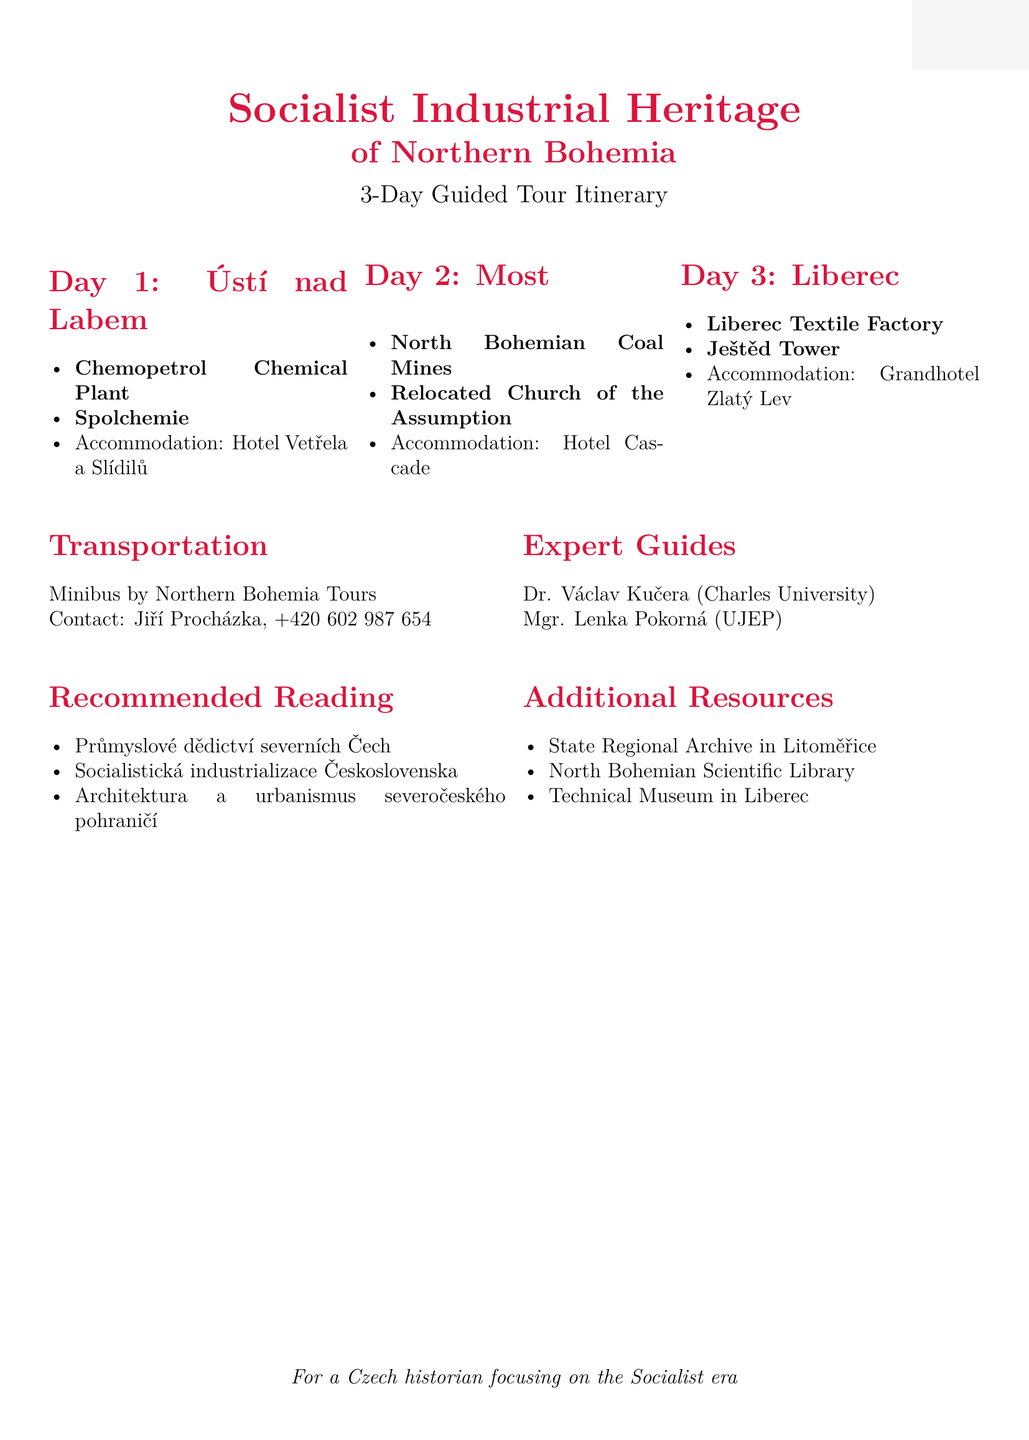What is the tour name? The tour name is stated at the beginning of the document.
Answer: Socialist Industrial Heritage of Northern Bohemia How many days does the tour last? The duration of the tour is mentioned clearly in the document.
Answer: 3 days Who is the contact person for Chemopetrol Chemical Plant? The document provides specific contacts for each site visited during the tour.
Answer: Miroslav Novák, Industrial Heritage Guide, +420 605 123 456 What type of transportation is provided? The document specifies the type of transport arranged for the tour.
Answer: Minibus What is the accommodation in Most? Each location in the tour lists its corresponding accommodation.
Answer: Hotel Cascade, Radniční 3, 434 01 Most Which expert guide specializes in economic history? The document lists expert guides along with their specializations.
Answer: Mgr. Lenka Pokorná When was the Ještěd Tower built? The document provides the construction period of the Ještěd Tower.
Answer: 1966-1973 What is the recommended reading author for the book "Socialistická industrializace Československa"? The recommended reading section lists various titles along with authors.
Answer: Martin Myška What is the address of the North Bohemian Scientific Library? The document provides specific locations for additional resources.
Answer: W. Churchilla 3, 400 01 Ústí nad Labem 